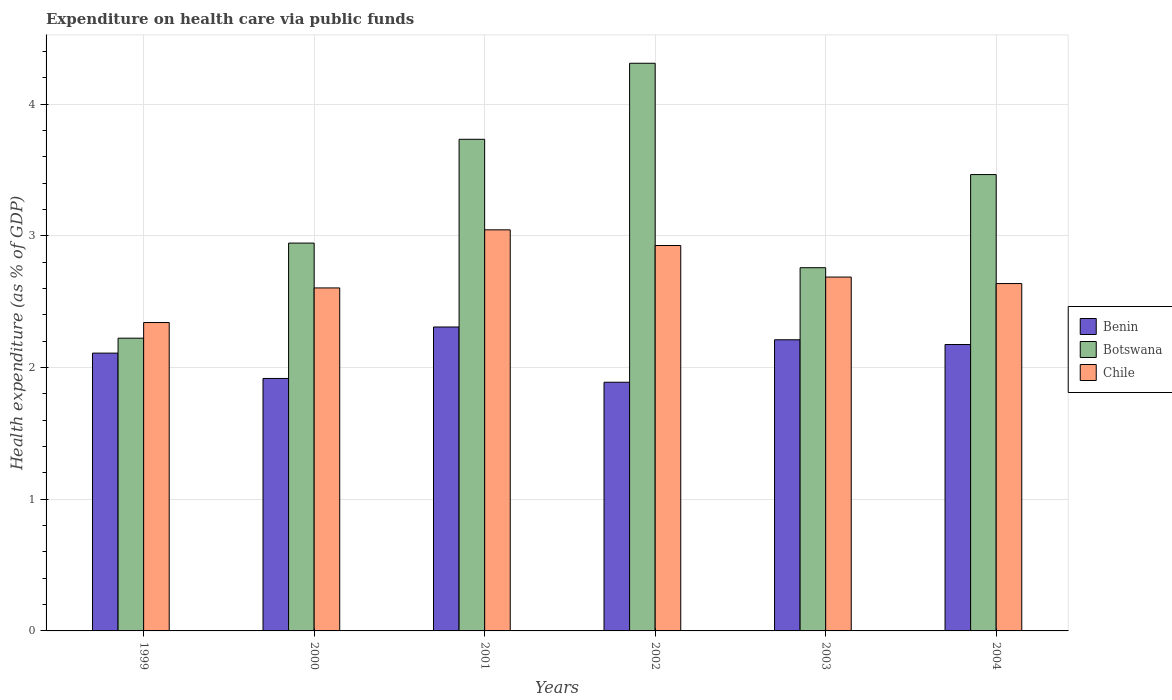How many different coloured bars are there?
Ensure brevity in your answer.  3. How many groups of bars are there?
Provide a short and direct response. 6. How many bars are there on the 3rd tick from the right?
Keep it short and to the point. 3. What is the label of the 2nd group of bars from the left?
Ensure brevity in your answer.  2000. In how many cases, is the number of bars for a given year not equal to the number of legend labels?
Ensure brevity in your answer.  0. What is the expenditure made on health care in Botswana in 2003?
Your answer should be very brief. 2.76. Across all years, what is the maximum expenditure made on health care in Benin?
Give a very brief answer. 2.31. Across all years, what is the minimum expenditure made on health care in Chile?
Your answer should be very brief. 2.34. What is the total expenditure made on health care in Botswana in the graph?
Give a very brief answer. 19.44. What is the difference between the expenditure made on health care in Benin in 2001 and that in 2003?
Make the answer very short. 0.1. What is the difference between the expenditure made on health care in Chile in 2001 and the expenditure made on health care in Benin in 2002?
Your answer should be compact. 1.16. What is the average expenditure made on health care in Botswana per year?
Make the answer very short. 3.24. In the year 2001, what is the difference between the expenditure made on health care in Botswana and expenditure made on health care in Benin?
Your response must be concise. 1.43. What is the ratio of the expenditure made on health care in Benin in 1999 to that in 2004?
Your response must be concise. 0.97. What is the difference between the highest and the second highest expenditure made on health care in Benin?
Your answer should be compact. 0.1. What is the difference between the highest and the lowest expenditure made on health care in Chile?
Offer a very short reply. 0.7. In how many years, is the expenditure made on health care in Botswana greater than the average expenditure made on health care in Botswana taken over all years?
Keep it short and to the point. 3. Is it the case that in every year, the sum of the expenditure made on health care in Benin and expenditure made on health care in Botswana is greater than the expenditure made on health care in Chile?
Make the answer very short. Yes. How many bars are there?
Offer a very short reply. 18. Does the graph contain any zero values?
Your answer should be very brief. No. Where does the legend appear in the graph?
Provide a succinct answer. Center right. How are the legend labels stacked?
Provide a succinct answer. Vertical. What is the title of the graph?
Keep it short and to the point. Expenditure on health care via public funds. Does "Antigua and Barbuda" appear as one of the legend labels in the graph?
Give a very brief answer. No. What is the label or title of the X-axis?
Your answer should be very brief. Years. What is the label or title of the Y-axis?
Your answer should be compact. Health expenditure (as % of GDP). What is the Health expenditure (as % of GDP) in Benin in 1999?
Ensure brevity in your answer.  2.11. What is the Health expenditure (as % of GDP) in Botswana in 1999?
Provide a succinct answer. 2.22. What is the Health expenditure (as % of GDP) in Chile in 1999?
Keep it short and to the point. 2.34. What is the Health expenditure (as % of GDP) in Benin in 2000?
Offer a very short reply. 1.92. What is the Health expenditure (as % of GDP) in Botswana in 2000?
Provide a succinct answer. 2.95. What is the Health expenditure (as % of GDP) in Chile in 2000?
Your answer should be compact. 2.6. What is the Health expenditure (as % of GDP) in Benin in 2001?
Your answer should be very brief. 2.31. What is the Health expenditure (as % of GDP) of Botswana in 2001?
Your answer should be compact. 3.73. What is the Health expenditure (as % of GDP) of Chile in 2001?
Offer a very short reply. 3.05. What is the Health expenditure (as % of GDP) in Benin in 2002?
Offer a terse response. 1.89. What is the Health expenditure (as % of GDP) in Botswana in 2002?
Make the answer very short. 4.31. What is the Health expenditure (as % of GDP) of Chile in 2002?
Your answer should be very brief. 2.93. What is the Health expenditure (as % of GDP) of Benin in 2003?
Your answer should be compact. 2.21. What is the Health expenditure (as % of GDP) of Botswana in 2003?
Your answer should be very brief. 2.76. What is the Health expenditure (as % of GDP) of Chile in 2003?
Make the answer very short. 2.69. What is the Health expenditure (as % of GDP) of Benin in 2004?
Make the answer very short. 2.18. What is the Health expenditure (as % of GDP) in Botswana in 2004?
Your response must be concise. 3.47. What is the Health expenditure (as % of GDP) of Chile in 2004?
Your answer should be compact. 2.64. Across all years, what is the maximum Health expenditure (as % of GDP) in Benin?
Give a very brief answer. 2.31. Across all years, what is the maximum Health expenditure (as % of GDP) of Botswana?
Give a very brief answer. 4.31. Across all years, what is the maximum Health expenditure (as % of GDP) of Chile?
Ensure brevity in your answer.  3.05. Across all years, what is the minimum Health expenditure (as % of GDP) in Benin?
Make the answer very short. 1.89. Across all years, what is the minimum Health expenditure (as % of GDP) in Botswana?
Keep it short and to the point. 2.22. Across all years, what is the minimum Health expenditure (as % of GDP) in Chile?
Provide a short and direct response. 2.34. What is the total Health expenditure (as % of GDP) of Benin in the graph?
Keep it short and to the point. 12.61. What is the total Health expenditure (as % of GDP) in Botswana in the graph?
Your response must be concise. 19.44. What is the total Health expenditure (as % of GDP) in Chile in the graph?
Ensure brevity in your answer.  16.25. What is the difference between the Health expenditure (as % of GDP) in Benin in 1999 and that in 2000?
Provide a short and direct response. 0.19. What is the difference between the Health expenditure (as % of GDP) in Botswana in 1999 and that in 2000?
Give a very brief answer. -0.72. What is the difference between the Health expenditure (as % of GDP) of Chile in 1999 and that in 2000?
Make the answer very short. -0.26. What is the difference between the Health expenditure (as % of GDP) in Benin in 1999 and that in 2001?
Your answer should be very brief. -0.2. What is the difference between the Health expenditure (as % of GDP) in Botswana in 1999 and that in 2001?
Keep it short and to the point. -1.51. What is the difference between the Health expenditure (as % of GDP) in Chile in 1999 and that in 2001?
Provide a short and direct response. -0.7. What is the difference between the Health expenditure (as % of GDP) in Benin in 1999 and that in 2002?
Provide a succinct answer. 0.22. What is the difference between the Health expenditure (as % of GDP) in Botswana in 1999 and that in 2002?
Provide a succinct answer. -2.09. What is the difference between the Health expenditure (as % of GDP) of Chile in 1999 and that in 2002?
Keep it short and to the point. -0.59. What is the difference between the Health expenditure (as % of GDP) in Benin in 1999 and that in 2003?
Your response must be concise. -0.1. What is the difference between the Health expenditure (as % of GDP) of Botswana in 1999 and that in 2003?
Offer a very short reply. -0.54. What is the difference between the Health expenditure (as % of GDP) in Chile in 1999 and that in 2003?
Offer a terse response. -0.35. What is the difference between the Health expenditure (as % of GDP) in Benin in 1999 and that in 2004?
Keep it short and to the point. -0.07. What is the difference between the Health expenditure (as % of GDP) of Botswana in 1999 and that in 2004?
Your answer should be very brief. -1.24. What is the difference between the Health expenditure (as % of GDP) in Chile in 1999 and that in 2004?
Give a very brief answer. -0.3. What is the difference between the Health expenditure (as % of GDP) in Benin in 2000 and that in 2001?
Provide a succinct answer. -0.39. What is the difference between the Health expenditure (as % of GDP) of Botswana in 2000 and that in 2001?
Offer a terse response. -0.79. What is the difference between the Health expenditure (as % of GDP) of Chile in 2000 and that in 2001?
Your answer should be very brief. -0.44. What is the difference between the Health expenditure (as % of GDP) of Benin in 2000 and that in 2002?
Your response must be concise. 0.03. What is the difference between the Health expenditure (as % of GDP) in Botswana in 2000 and that in 2002?
Make the answer very short. -1.37. What is the difference between the Health expenditure (as % of GDP) in Chile in 2000 and that in 2002?
Offer a very short reply. -0.32. What is the difference between the Health expenditure (as % of GDP) in Benin in 2000 and that in 2003?
Your answer should be very brief. -0.29. What is the difference between the Health expenditure (as % of GDP) in Botswana in 2000 and that in 2003?
Your response must be concise. 0.19. What is the difference between the Health expenditure (as % of GDP) in Chile in 2000 and that in 2003?
Keep it short and to the point. -0.08. What is the difference between the Health expenditure (as % of GDP) of Benin in 2000 and that in 2004?
Provide a succinct answer. -0.26. What is the difference between the Health expenditure (as % of GDP) in Botswana in 2000 and that in 2004?
Provide a succinct answer. -0.52. What is the difference between the Health expenditure (as % of GDP) in Chile in 2000 and that in 2004?
Your answer should be compact. -0.03. What is the difference between the Health expenditure (as % of GDP) in Benin in 2001 and that in 2002?
Your answer should be very brief. 0.42. What is the difference between the Health expenditure (as % of GDP) of Botswana in 2001 and that in 2002?
Ensure brevity in your answer.  -0.58. What is the difference between the Health expenditure (as % of GDP) of Chile in 2001 and that in 2002?
Your response must be concise. 0.12. What is the difference between the Health expenditure (as % of GDP) in Benin in 2001 and that in 2003?
Offer a terse response. 0.1. What is the difference between the Health expenditure (as % of GDP) of Botswana in 2001 and that in 2003?
Provide a succinct answer. 0.98. What is the difference between the Health expenditure (as % of GDP) of Chile in 2001 and that in 2003?
Give a very brief answer. 0.36. What is the difference between the Health expenditure (as % of GDP) of Benin in 2001 and that in 2004?
Keep it short and to the point. 0.13. What is the difference between the Health expenditure (as % of GDP) in Botswana in 2001 and that in 2004?
Offer a very short reply. 0.27. What is the difference between the Health expenditure (as % of GDP) in Chile in 2001 and that in 2004?
Your answer should be very brief. 0.41. What is the difference between the Health expenditure (as % of GDP) in Benin in 2002 and that in 2003?
Provide a succinct answer. -0.32. What is the difference between the Health expenditure (as % of GDP) in Botswana in 2002 and that in 2003?
Your response must be concise. 1.55. What is the difference between the Health expenditure (as % of GDP) in Chile in 2002 and that in 2003?
Provide a succinct answer. 0.24. What is the difference between the Health expenditure (as % of GDP) in Benin in 2002 and that in 2004?
Provide a succinct answer. -0.29. What is the difference between the Health expenditure (as % of GDP) of Botswana in 2002 and that in 2004?
Your answer should be very brief. 0.85. What is the difference between the Health expenditure (as % of GDP) of Chile in 2002 and that in 2004?
Keep it short and to the point. 0.29. What is the difference between the Health expenditure (as % of GDP) in Benin in 2003 and that in 2004?
Provide a short and direct response. 0.04. What is the difference between the Health expenditure (as % of GDP) in Botswana in 2003 and that in 2004?
Keep it short and to the point. -0.71. What is the difference between the Health expenditure (as % of GDP) of Chile in 2003 and that in 2004?
Your answer should be very brief. 0.05. What is the difference between the Health expenditure (as % of GDP) in Benin in 1999 and the Health expenditure (as % of GDP) in Botswana in 2000?
Your answer should be very brief. -0.84. What is the difference between the Health expenditure (as % of GDP) of Benin in 1999 and the Health expenditure (as % of GDP) of Chile in 2000?
Offer a terse response. -0.5. What is the difference between the Health expenditure (as % of GDP) in Botswana in 1999 and the Health expenditure (as % of GDP) in Chile in 2000?
Your answer should be very brief. -0.38. What is the difference between the Health expenditure (as % of GDP) of Benin in 1999 and the Health expenditure (as % of GDP) of Botswana in 2001?
Offer a terse response. -1.62. What is the difference between the Health expenditure (as % of GDP) in Benin in 1999 and the Health expenditure (as % of GDP) in Chile in 2001?
Keep it short and to the point. -0.94. What is the difference between the Health expenditure (as % of GDP) in Botswana in 1999 and the Health expenditure (as % of GDP) in Chile in 2001?
Your answer should be compact. -0.82. What is the difference between the Health expenditure (as % of GDP) of Benin in 1999 and the Health expenditure (as % of GDP) of Botswana in 2002?
Provide a succinct answer. -2.2. What is the difference between the Health expenditure (as % of GDP) of Benin in 1999 and the Health expenditure (as % of GDP) of Chile in 2002?
Provide a succinct answer. -0.82. What is the difference between the Health expenditure (as % of GDP) in Botswana in 1999 and the Health expenditure (as % of GDP) in Chile in 2002?
Your answer should be compact. -0.7. What is the difference between the Health expenditure (as % of GDP) in Benin in 1999 and the Health expenditure (as % of GDP) in Botswana in 2003?
Provide a succinct answer. -0.65. What is the difference between the Health expenditure (as % of GDP) of Benin in 1999 and the Health expenditure (as % of GDP) of Chile in 2003?
Keep it short and to the point. -0.58. What is the difference between the Health expenditure (as % of GDP) of Botswana in 1999 and the Health expenditure (as % of GDP) of Chile in 2003?
Offer a very short reply. -0.46. What is the difference between the Health expenditure (as % of GDP) of Benin in 1999 and the Health expenditure (as % of GDP) of Botswana in 2004?
Your answer should be compact. -1.36. What is the difference between the Health expenditure (as % of GDP) of Benin in 1999 and the Health expenditure (as % of GDP) of Chile in 2004?
Your answer should be very brief. -0.53. What is the difference between the Health expenditure (as % of GDP) of Botswana in 1999 and the Health expenditure (as % of GDP) of Chile in 2004?
Your response must be concise. -0.41. What is the difference between the Health expenditure (as % of GDP) in Benin in 2000 and the Health expenditure (as % of GDP) in Botswana in 2001?
Your response must be concise. -1.82. What is the difference between the Health expenditure (as % of GDP) in Benin in 2000 and the Health expenditure (as % of GDP) in Chile in 2001?
Your answer should be compact. -1.13. What is the difference between the Health expenditure (as % of GDP) of Botswana in 2000 and the Health expenditure (as % of GDP) of Chile in 2001?
Give a very brief answer. -0.1. What is the difference between the Health expenditure (as % of GDP) in Benin in 2000 and the Health expenditure (as % of GDP) in Botswana in 2002?
Keep it short and to the point. -2.39. What is the difference between the Health expenditure (as % of GDP) of Benin in 2000 and the Health expenditure (as % of GDP) of Chile in 2002?
Provide a short and direct response. -1.01. What is the difference between the Health expenditure (as % of GDP) of Botswana in 2000 and the Health expenditure (as % of GDP) of Chile in 2002?
Your answer should be very brief. 0.02. What is the difference between the Health expenditure (as % of GDP) in Benin in 2000 and the Health expenditure (as % of GDP) in Botswana in 2003?
Give a very brief answer. -0.84. What is the difference between the Health expenditure (as % of GDP) of Benin in 2000 and the Health expenditure (as % of GDP) of Chile in 2003?
Give a very brief answer. -0.77. What is the difference between the Health expenditure (as % of GDP) in Botswana in 2000 and the Health expenditure (as % of GDP) in Chile in 2003?
Offer a terse response. 0.26. What is the difference between the Health expenditure (as % of GDP) of Benin in 2000 and the Health expenditure (as % of GDP) of Botswana in 2004?
Give a very brief answer. -1.55. What is the difference between the Health expenditure (as % of GDP) of Benin in 2000 and the Health expenditure (as % of GDP) of Chile in 2004?
Your response must be concise. -0.72. What is the difference between the Health expenditure (as % of GDP) of Botswana in 2000 and the Health expenditure (as % of GDP) of Chile in 2004?
Your answer should be very brief. 0.31. What is the difference between the Health expenditure (as % of GDP) in Benin in 2001 and the Health expenditure (as % of GDP) in Botswana in 2002?
Your answer should be compact. -2. What is the difference between the Health expenditure (as % of GDP) in Benin in 2001 and the Health expenditure (as % of GDP) in Chile in 2002?
Offer a terse response. -0.62. What is the difference between the Health expenditure (as % of GDP) in Botswana in 2001 and the Health expenditure (as % of GDP) in Chile in 2002?
Offer a terse response. 0.81. What is the difference between the Health expenditure (as % of GDP) in Benin in 2001 and the Health expenditure (as % of GDP) in Botswana in 2003?
Your answer should be compact. -0.45. What is the difference between the Health expenditure (as % of GDP) of Benin in 2001 and the Health expenditure (as % of GDP) of Chile in 2003?
Your answer should be compact. -0.38. What is the difference between the Health expenditure (as % of GDP) of Botswana in 2001 and the Health expenditure (as % of GDP) of Chile in 2003?
Offer a terse response. 1.05. What is the difference between the Health expenditure (as % of GDP) in Benin in 2001 and the Health expenditure (as % of GDP) in Botswana in 2004?
Your response must be concise. -1.16. What is the difference between the Health expenditure (as % of GDP) of Benin in 2001 and the Health expenditure (as % of GDP) of Chile in 2004?
Ensure brevity in your answer.  -0.33. What is the difference between the Health expenditure (as % of GDP) of Botswana in 2001 and the Health expenditure (as % of GDP) of Chile in 2004?
Give a very brief answer. 1.1. What is the difference between the Health expenditure (as % of GDP) in Benin in 2002 and the Health expenditure (as % of GDP) in Botswana in 2003?
Make the answer very short. -0.87. What is the difference between the Health expenditure (as % of GDP) in Benin in 2002 and the Health expenditure (as % of GDP) in Chile in 2003?
Provide a short and direct response. -0.8. What is the difference between the Health expenditure (as % of GDP) in Botswana in 2002 and the Health expenditure (as % of GDP) in Chile in 2003?
Offer a very short reply. 1.62. What is the difference between the Health expenditure (as % of GDP) in Benin in 2002 and the Health expenditure (as % of GDP) in Botswana in 2004?
Provide a short and direct response. -1.58. What is the difference between the Health expenditure (as % of GDP) of Benin in 2002 and the Health expenditure (as % of GDP) of Chile in 2004?
Provide a short and direct response. -0.75. What is the difference between the Health expenditure (as % of GDP) of Botswana in 2002 and the Health expenditure (as % of GDP) of Chile in 2004?
Provide a short and direct response. 1.67. What is the difference between the Health expenditure (as % of GDP) of Benin in 2003 and the Health expenditure (as % of GDP) of Botswana in 2004?
Ensure brevity in your answer.  -1.25. What is the difference between the Health expenditure (as % of GDP) in Benin in 2003 and the Health expenditure (as % of GDP) in Chile in 2004?
Provide a short and direct response. -0.43. What is the difference between the Health expenditure (as % of GDP) in Botswana in 2003 and the Health expenditure (as % of GDP) in Chile in 2004?
Offer a very short reply. 0.12. What is the average Health expenditure (as % of GDP) of Benin per year?
Your answer should be very brief. 2.1. What is the average Health expenditure (as % of GDP) of Botswana per year?
Offer a terse response. 3.24. What is the average Health expenditure (as % of GDP) of Chile per year?
Your answer should be very brief. 2.71. In the year 1999, what is the difference between the Health expenditure (as % of GDP) of Benin and Health expenditure (as % of GDP) of Botswana?
Provide a short and direct response. -0.11. In the year 1999, what is the difference between the Health expenditure (as % of GDP) of Benin and Health expenditure (as % of GDP) of Chile?
Give a very brief answer. -0.23. In the year 1999, what is the difference between the Health expenditure (as % of GDP) of Botswana and Health expenditure (as % of GDP) of Chile?
Give a very brief answer. -0.12. In the year 2000, what is the difference between the Health expenditure (as % of GDP) of Benin and Health expenditure (as % of GDP) of Botswana?
Your answer should be very brief. -1.03. In the year 2000, what is the difference between the Health expenditure (as % of GDP) in Benin and Health expenditure (as % of GDP) in Chile?
Provide a succinct answer. -0.69. In the year 2000, what is the difference between the Health expenditure (as % of GDP) in Botswana and Health expenditure (as % of GDP) in Chile?
Keep it short and to the point. 0.34. In the year 2001, what is the difference between the Health expenditure (as % of GDP) in Benin and Health expenditure (as % of GDP) in Botswana?
Provide a succinct answer. -1.43. In the year 2001, what is the difference between the Health expenditure (as % of GDP) of Benin and Health expenditure (as % of GDP) of Chile?
Your answer should be compact. -0.74. In the year 2001, what is the difference between the Health expenditure (as % of GDP) of Botswana and Health expenditure (as % of GDP) of Chile?
Ensure brevity in your answer.  0.69. In the year 2002, what is the difference between the Health expenditure (as % of GDP) in Benin and Health expenditure (as % of GDP) in Botswana?
Your answer should be compact. -2.42. In the year 2002, what is the difference between the Health expenditure (as % of GDP) in Benin and Health expenditure (as % of GDP) in Chile?
Your answer should be very brief. -1.04. In the year 2002, what is the difference between the Health expenditure (as % of GDP) in Botswana and Health expenditure (as % of GDP) in Chile?
Offer a very short reply. 1.38. In the year 2003, what is the difference between the Health expenditure (as % of GDP) in Benin and Health expenditure (as % of GDP) in Botswana?
Keep it short and to the point. -0.55. In the year 2003, what is the difference between the Health expenditure (as % of GDP) of Benin and Health expenditure (as % of GDP) of Chile?
Give a very brief answer. -0.48. In the year 2003, what is the difference between the Health expenditure (as % of GDP) of Botswana and Health expenditure (as % of GDP) of Chile?
Provide a short and direct response. 0.07. In the year 2004, what is the difference between the Health expenditure (as % of GDP) of Benin and Health expenditure (as % of GDP) of Botswana?
Ensure brevity in your answer.  -1.29. In the year 2004, what is the difference between the Health expenditure (as % of GDP) in Benin and Health expenditure (as % of GDP) in Chile?
Your answer should be very brief. -0.46. In the year 2004, what is the difference between the Health expenditure (as % of GDP) of Botswana and Health expenditure (as % of GDP) of Chile?
Provide a succinct answer. 0.83. What is the ratio of the Health expenditure (as % of GDP) in Benin in 1999 to that in 2000?
Offer a very short reply. 1.1. What is the ratio of the Health expenditure (as % of GDP) in Botswana in 1999 to that in 2000?
Provide a short and direct response. 0.75. What is the ratio of the Health expenditure (as % of GDP) of Chile in 1999 to that in 2000?
Ensure brevity in your answer.  0.9. What is the ratio of the Health expenditure (as % of GDP) of Benin in 1999 to that in 2001?
Offer a very short reply. 0.91. What is the ratio of the Health expenditure (as % of GDP) in Botswana in 1999 to that in 2001?
Your answer should be compact. 0.6. What is the ratio of the Health expenditure (as % of GDP) in Chile in 1999 to that in 2001?
Your answer should be very brief. 0.77. What is the ratio of the Health expenditure (as % of GDP) in Benin in 1999 to that in 2002?
Keep it short and to the point. 1.12. What is the ratio of the Health expenditure (as % of GDP) of Botswana in 1999 to that in 2002?
Offer a terse response. 0.52. What is the ratio of the Health expenditure (as % of GDP) in Chile in 1999 to that in 2002?
Offer a terse response. 0.8. What is the ratio of the Health expenditure (as % of GDP) of Benin in 1999 to that in 2003?
Provide a short and direct response. 0.95. What is the ratio of the Health expenditure (as % of GDP) of Botswana in 1999 to that in 2003?
Give a very brief answer. 0.81. What is the ratio of the Health expenditure (as % of GDP) of Chile in 1999 to that in 2003?
Ensure brevity in your answer.  0.87. What is the ratio of the Health expenditure (as % of GDP) of Botswana in 1999 to that in 2004?
Your answer should be very brief. 0.64. What is the ratio of the Health expenditure (as % of GDP) in Chile in 1999 to that in 2004?
Provide a short and direct response. 0.89. What is the ratio of the Health expenditure (as % of GDP) in Benin in 2000 to that in 2001?
Ensure brevity in your answer.  0.83. What is the ratio of the Health expenditure (as % of GDP) of Botswana in 2000 to that in 2001?
Your answer should be compact. 0.79. What is the ratio of the Health expenditure (as % of GDP) in Chile in 2000 to that in 2001?
Your response must be concise. 0.86. What is the ratio of the Health expenditure (as % of GDP) of Benin in 2000 to that in 2002?
Your answer should be very brief. 1.02. What is the ratio of the Health expenditure (as % of GDP) of Botswana in 2000 to that in 2002?
Your response must be concise. 0.68. What is the ratio of the Health expenditure (as % of GDP) of Chile in 2000 to that in 2002?
Provide a short and direct response. 0.89. What is the ratio of the Health expenditure (as % of GDP) of Benin in 2000 to that in 2003?
Offer a very short reply. 0.87. What is the ratio of the Health expenditure (as % of GDP) of Botswana in 2000 to that in 2003?
Give a very brief answer. 1.07. What is the ratio of the Health expenditure (as % of GDP) of Chile in 2000 to that in 2003?
Keep it short and to the point. 0.97. What is the ratio of the Health expenditure (as % of GDP) of Benin in 2000 to that in 2004?
Give a very brief answer. 0.88. What is the ratio of the Health expenditure (as % of GDP) in Botswana in 2000 to that in 2004?
Your response must be concise. 0.85. What is the ratio of the Health expenditure (as % of GDP) in Chile in 2000 to that in 2004?
Give a very brief answer. 0.99. What is the ratio of the Health expenditure (as % of GDP) in Benin in 2001 to that in 2002?
Ensure brevity in your answer.  1.22. What is the ratio of the Health expenditure (as % of GDP) of Botswana in 2001 to that in 2002?
Your response must be concise. 0.87. What is the ratio of the Health expenditure (as % of GDP) in Chile in 2001 to that in 2002?
Keep it short and to the point. 1.04. What is the ratio of the Health expenditure (as % of GDP) of Benin in 2001 to that in 2003?
Provide a succinct answer. 1.04. What is the ratio of the Health expenditure (as % of GDP) of Botswana in 2001 to that in 2003?
Your response must be concise. 1.35. What is the ratio of the Health expenditure (as % of GDP) in Chile in 2001 to that in 2003?
Your response must be concise. 1.13. What is the ratio of the Health expenditure (as % of GDP) in Benin in 2001 to that in 2004?
Offer a terse response. 1.06. What is the ratio of the Health expenditure (as % of GDP) of Botswana in 2001 to that in 2004?
Provide a succinct answer. 1.08. What is the ratio of the Health expenditure (as % of GDP) in Chile in 2001 to that in 2004?
Offer a very short reply. 1.15. What is the ratio of the Health expenditure (as % of GDP) of Benin in 2002 to that in 2003?
Your answer should be compact. 0.85. What is the ratio of the Health expenditure (as % of GDP) in Botswana in 2002 to that in 2003?
Offer a very short reply. 1.56. What is the ratio of the Health expenditure (as % of GDP) in Chile in 2002 to that in 2003?
Offer a very short reply. 1.09. What is the ratio of the Health expenditure (as % of GDP) of Benin in 2002 to that in 2004?
Provide a short and direct response. 0.87. What is the ratio of the Health expenditure (as % of GDP) in Botswana in 2002 to that in 2004?
Ensure brevity in your answer.  1.24. What is the ratio of the Health expenditure (as % of GDP) in Chile in 2002 to that in 2004?
Ensure brevity in your answer.  1.11. What is the ratio of the Health expenditure (as % of GDP) in Benin in 2003 to that in 2004?
Ensure brevity in your answer.  1.02. What is the ratio of the Health expenditure (as % of GDP) of Botswana in 2003 to that in 2004?
Your response must be concise. 0.8. What is the ratio of the Health expenditure (as % of GDP) in Chile in 2003 to that in 2004?
Make the answer very short. 1.02. What is the difference between the highest and the second highest Health expenditure (as % of GDP) of Benin?
Keep it short and to the point. 0.1. What is the difference between the highest and the second highest Health expenditure (as % of GDP) in Botswana?
Offer a very short reply. 0.58. What is the difference between the highest and the second highest Health expenditure (as % of GDP) in Chile?
Keep it short and to the point. 0.12. What is the difference between the highest and the lowest Health expenditure (as % of GDP) in Benin?
Your response must be concise. 0.42. What is the difference between the highest and the lowest Health expenditure (as % of GDP) in Botswana?
Your answer should be very brief. 2.09. What is the difference between the highest and the lowest Health expenditure (as % of GDP) of Chile?
Keep it short and to the point. 0.7. 